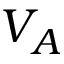Convert formula to latex. <formula><loc_0><loc_0><loc_500><loc_500>V _ { A }</formula> 